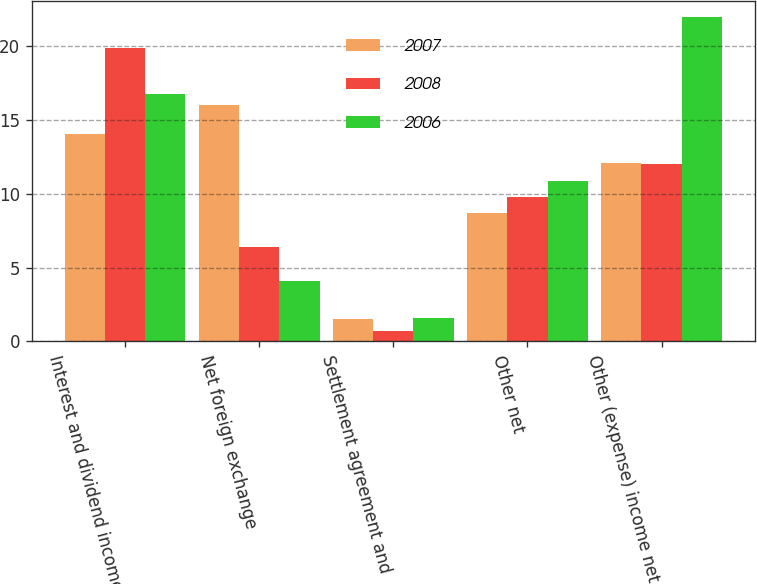Convert chart to OTSL. <chart><loc_0><loc_0><loc_500><loc_500><stacked_bar_chart><ecel><fcel>Interest and dividend income<fcel>Net foreign exchange<fcel>Settlement agreement and<fcel>Other net<fcel>Other (expense) income net<nl><fcel>2007<fcel>14.1<fcel>16<fcel>1.5<fcel>8.7<fcel>12.1<nl><fcel>2008<fcel>19.9<fcel>6.4<fcel>0.7<fcel>9.8<fcel>12<nl><fcel>2006<fcel>16.8<fcel>4.1<fcel>1.6<fcel>10.9<fcel>22<nl></chart> 